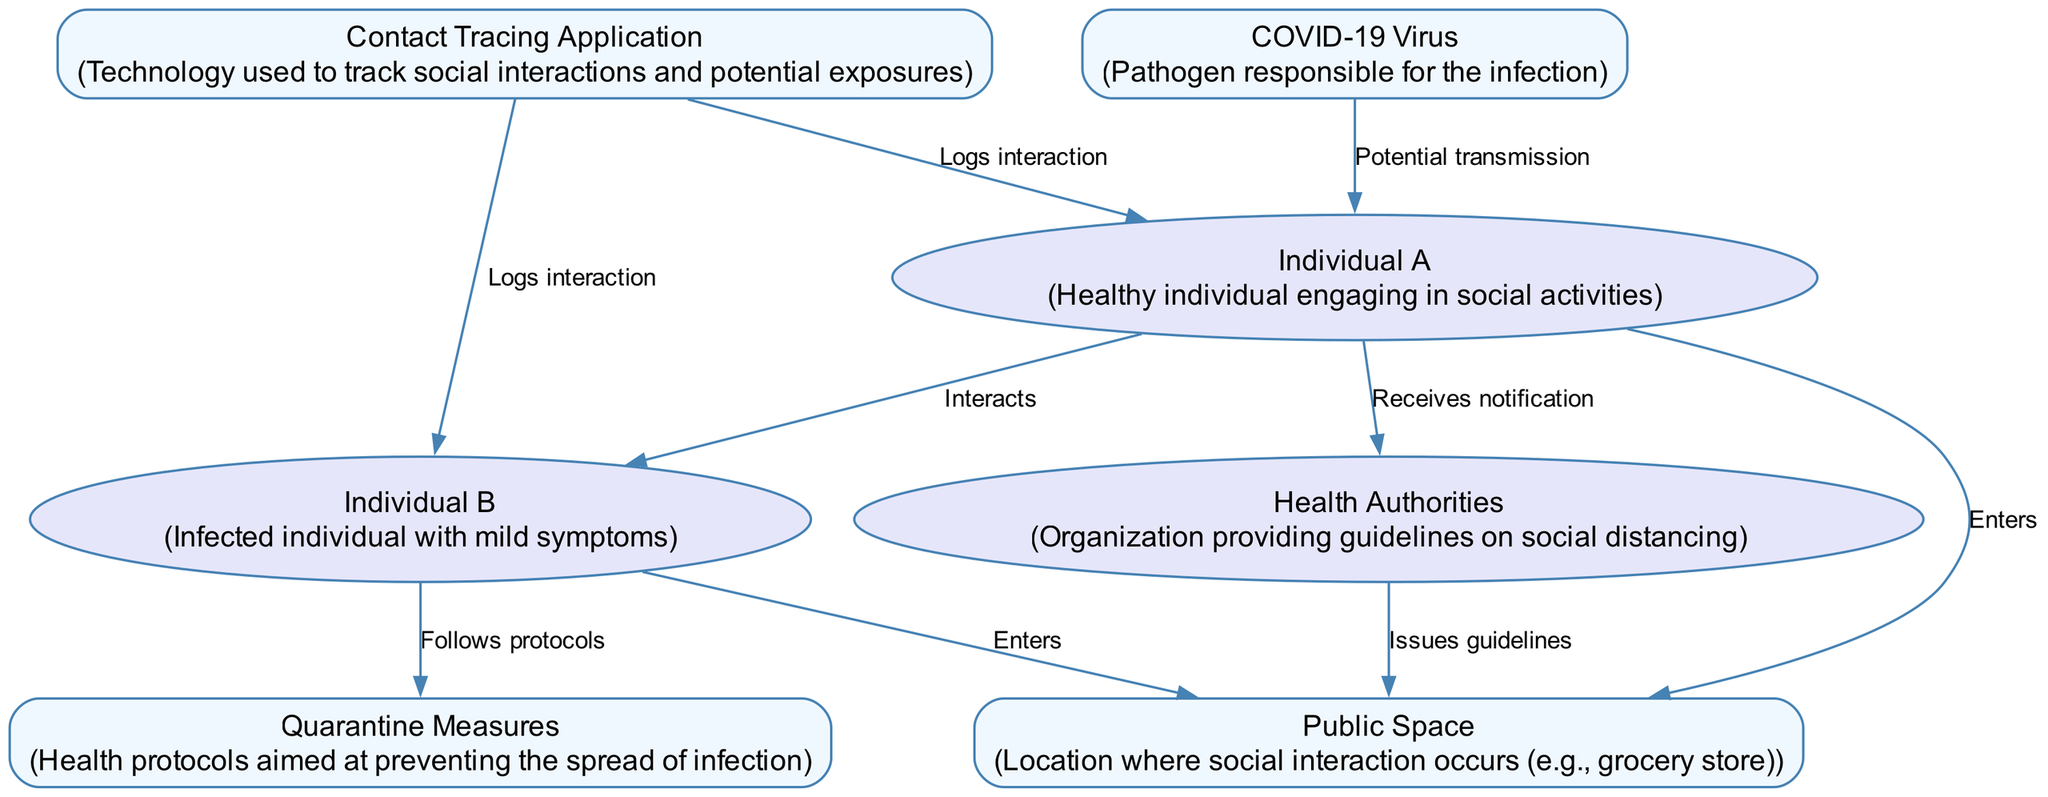What are the two main actors involved in the interaction? The diagram identifies two main actors: Individual A (a healthy individual) and Individual B (an infected individual). These are represented in distinct roles that highlight their relevance to the interaction.
Answer: Individual A and Individual B How many entities are present in the diagram? The diagram includes three entities: Public Space, COVID-19 Virus, and Contact Tracing Application. Counting these gives the total number of entities present.
Answer: Three What action occurs between Individual A and Individual B? The diagram shows that Individual A and Individual B interact with each other. This is specifically labeled as "Interacts" and is a key point in the transmission potential.
Answer: Interacts Which entity logs the interaction for both individuals? The Contact Tracing Application is responsible for logging interactions. In the diagram, it is shown explicitly that it logs interactions for both Individual A and Individual B.
Answer: Contact Tracing Application What measure does Individual B follow after entering the Public Space? After entering the Public Space, Individual B follows Quarantine Measures. This is indicated in the diagram as a response to the interaction and potential exposure.
Answer: Quarantine Measures Which entity issues guidelines regarding social distancing? Health Authorities are the entity that issues guidelines concerning social distancing in the public space. This is outlined in the sequence of interactions showing their role.
Answer: Health Authorities What potential event occurs from the COVID-19 Virus to Individual A? The potential event that occurs is "Potential transmission." This is indicated in the diagram, where the virus is shown to be related to the interaction with Individual A.
Answer: Potential transmission How many interactions are logged by the Contact Tracing Application? The Contact Tracing Application logs two interactions: one for Individual A and one for Individual B. Each interaction is explicitly labeled in the diagram.
Answer: Two What is the first action taken by Individual A in the sequence? The first action taken by Individual A is to enter the Public Space. This is noted as the initial interaction sequence in the diagram.
Answer: Enters 